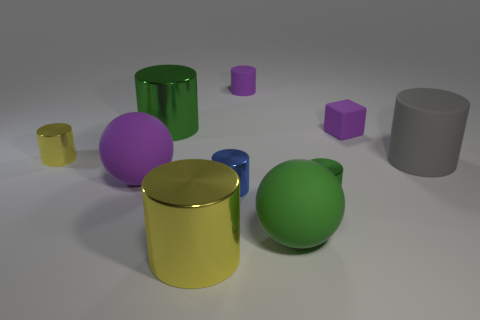Do the green sphere and the purple matte cube have the same size?
Give a very brief answer. No. What number of cylinders are either tiny gray shiny things or big metal things?
Provide a succinct answer. 2. How many rubber spheres are left of the tiny blue metallic object and to the right of the large green cylinder?
Provide a short and direct response. 0. There is a gray cylinder; does it have the same size as the yellow thing behind the gray matte thing?
Make the answer very short. No. Is there a large purple object behind the small purple thing that is left of the green shiny object that is right of the small rubber cylinder?
Your response must be concise. No. What is the material of the large object that is behind the tiny metallic object left of the large yellow object?
Your answer should be compact. Metal. The tiny thing that is in front of the small rubber cube and behind the small blue cylinder is made of what material?
Provide a short and direct response. Metal. Is there a yellow rubber thing that has the same shape as the tiny blue thing?
Provide a succinct answer. No. Are there any blue shiny cylinders behind the tiny rubber thing that is to the right of the green matte thing?
Offer a terse response. No. How many tiny blocks have the same material as the gray cylinder?
Provide a succinct answer. 1. 